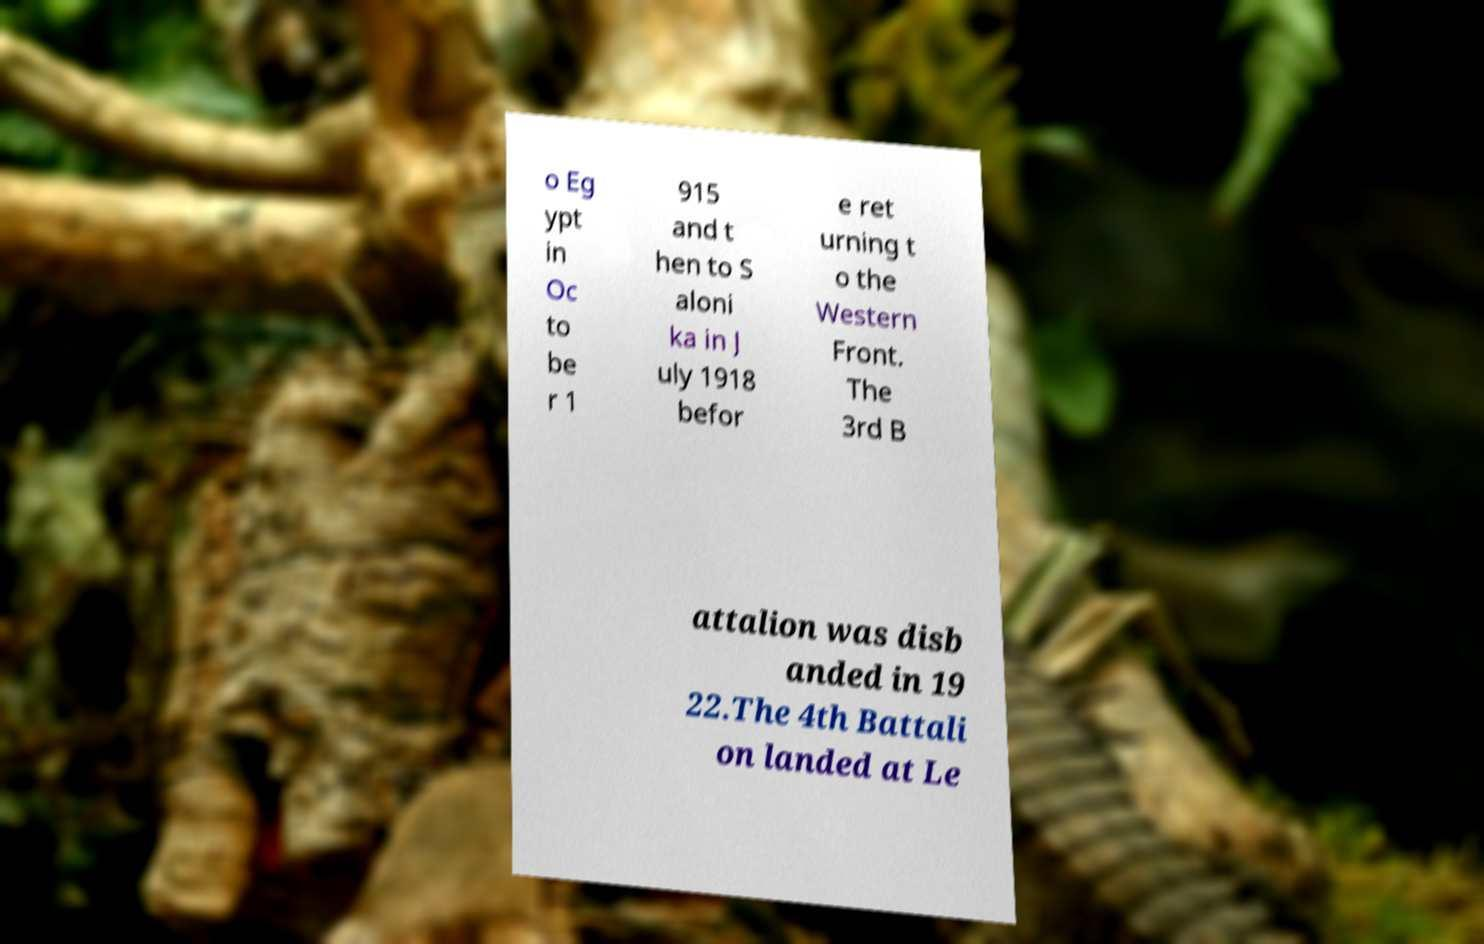Can you accurately transcribe the text from the provided image for me? o Eg ypt in Oc to be r 1 915 and t hen to S aloni ka in J uly 1918 befor e ret urning t o the Western Front. The 3rd B attalion was disb anded in 19 22.The 4th Battali on landed at Le 